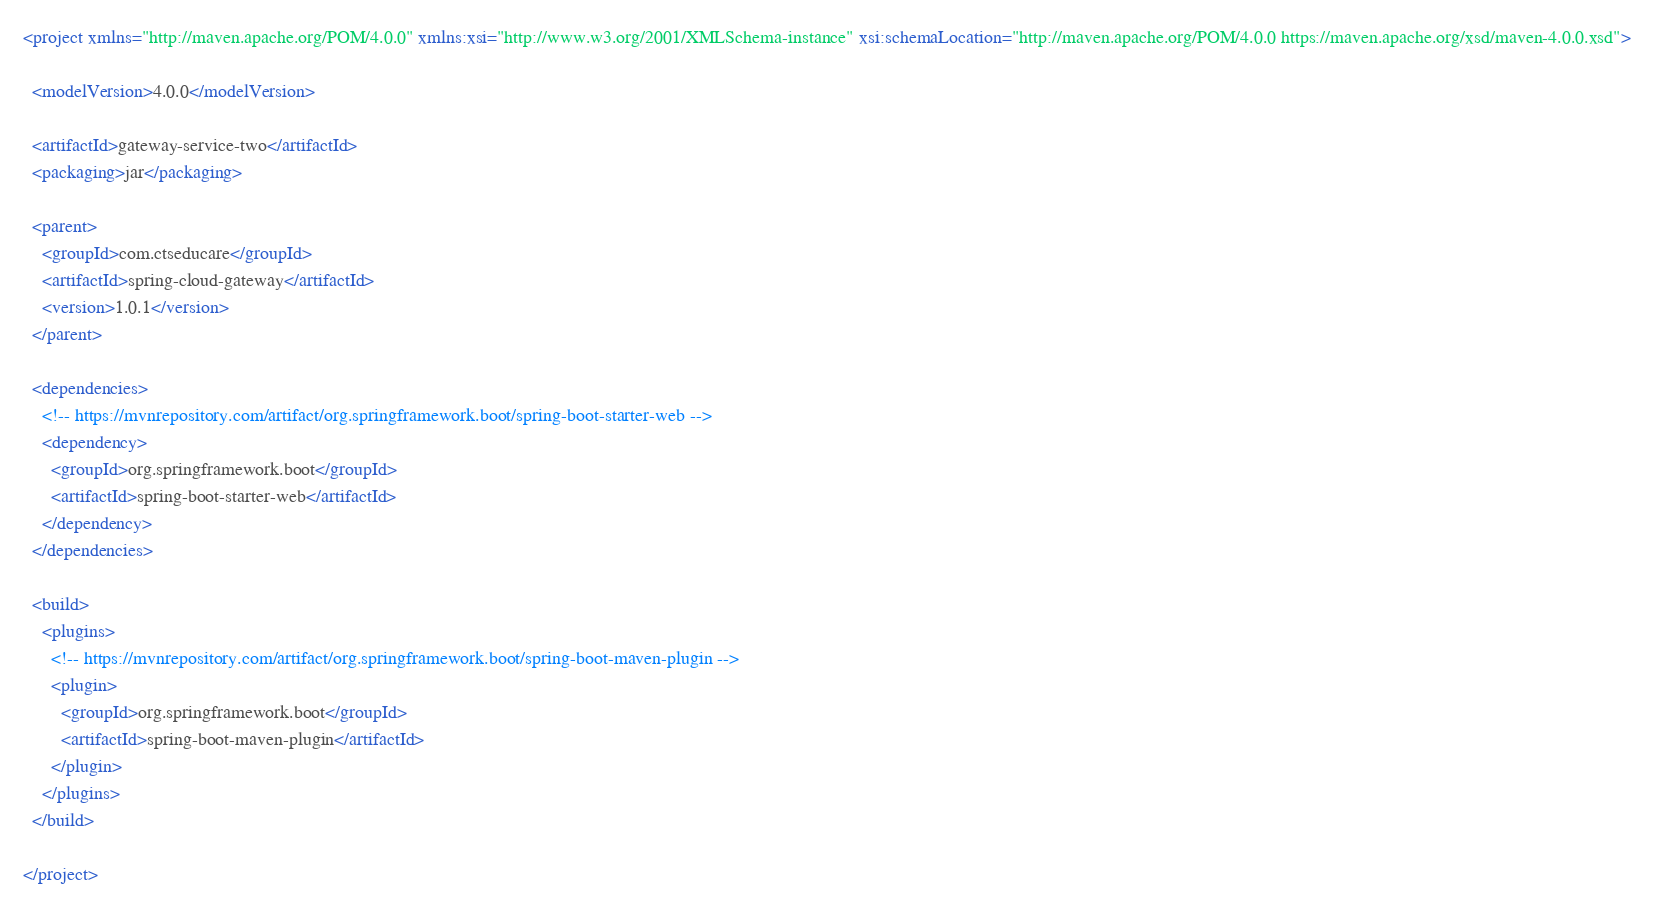Convert code to text. <code><loc_0><loc_0><loc_500><loc_500><_XML_><project xmlns="http://maven.apache.org/POM/4.0.0" xmlns:xsi="http://www.w3.org/2001/XMLSchema-instance" xsi:schemaLocation="http://maven.apache.org/POM/4.0.0 https://maven.apache.org/xsd/maven-4.0.0.xsd">

  <modelVersion>4.0.0</modelVersion>

  <artifactId>gateway-service-two</artifactId>
  <packaging>jar</packaging>
  
  <parent>
    <groupId>com.ctseducare</groupId>
    <artifactId>spring-cloud-gateway</artifactId>
    <version>1.0.1</version>
  </parent>

  <dependencies>
    <!-- https://mvnrepository.com/artifact/org.springframework.boot/spring-boot-starter-web -->
    <dependency>
      <groupId>org.springframework.boot</groupId>
      <artifactId>spring-boot-starter-web</artifactId>
    </dependency>
  </dependencies>
  
  <build>
    <plugins>
      <!-- https://mvnrepository.com/artifact/org.springframework.boot/spring-boot-maven-plugin -->
      <plugin>
        <groupId>org.springframework.boot</groupId>
        <artifactId>spring-boot-maven-plugin</artifactId>
      </plugin>
    </plugins>
  </build>  

</project></code> 